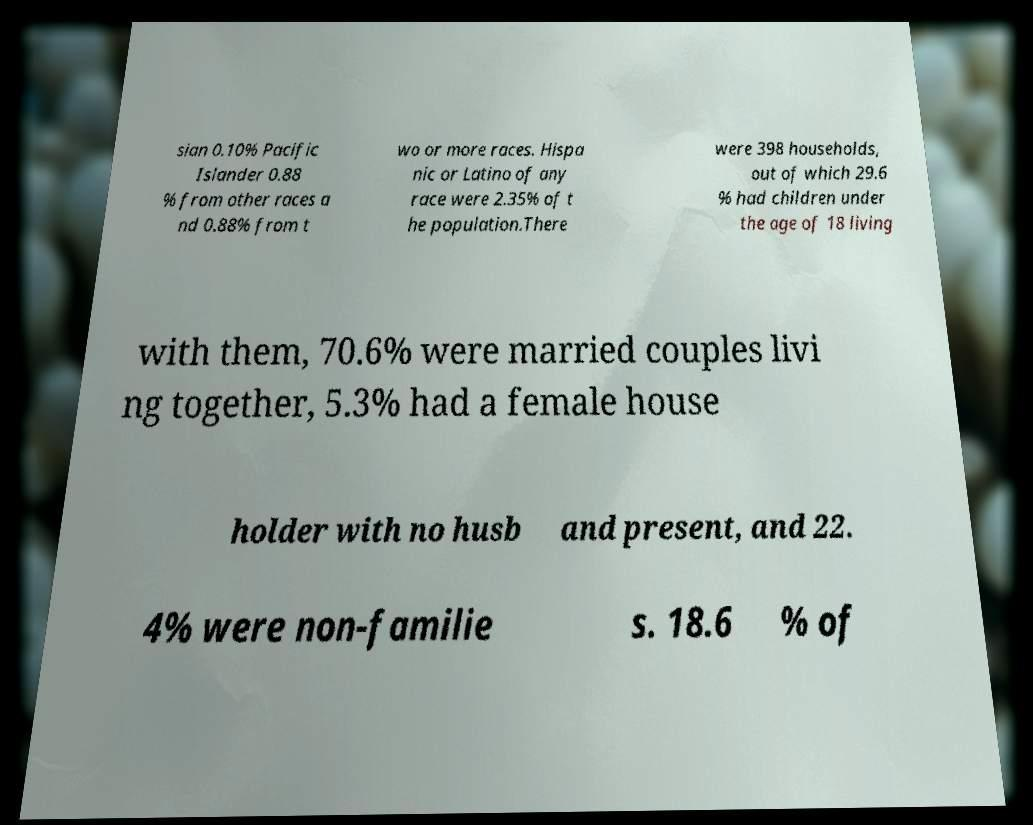What messages or text are displayed in this image? I need them in a readable, typed format. sian 0.10% Pacific Islander 0.88 % from other races a nd 0.88% from t wo or more races. Hispa nic or Latino of any race were 2.35% of t he population.There were 398 households, out of which 29.6 % had children under the age of 18 living with them, 70.6% were married couples livi ng together, 5.3% had a female house holder with no husb and present, and 22. 4% were non-familie s. 18.6 % of 